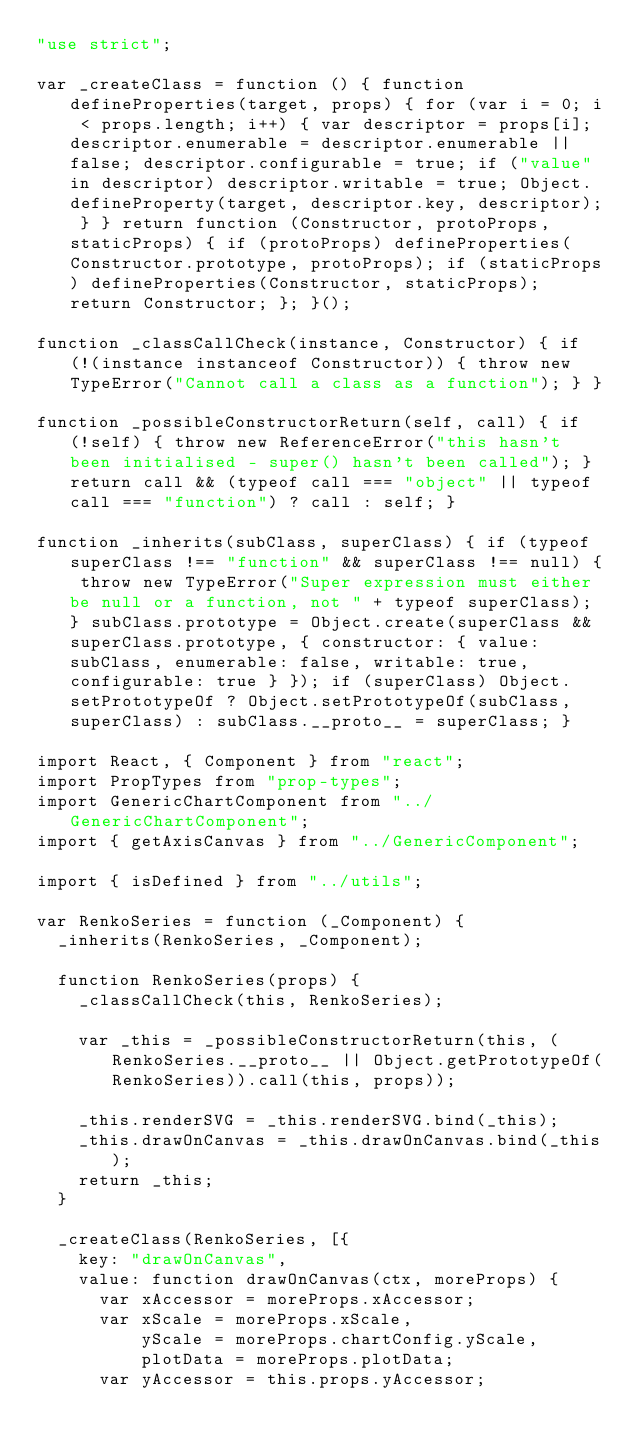Convert code to text. <code><loc_0><loc_0><loc_500><loc_500><_JavaScript_>"use strict";

var _createClass = function () { function defineProperties(target, props) { for (var i = 0; i < props.length; i++) { var descriptor = props[i]; descriptor.enumerable = descriptor.enumerable || false; descriptor.configurable = true; if ("value" in descriptor) descriptor.writable = true; Object.defineProperty(target, descriptor.key, descriptor); } } return function (Constructor, protoProps, staticProps) { if (protoProps) defineProperties(Constructor.prototype, protoProps); if (staticProps) defineProperties(Constructor, staticProps); return Constructor; }; }();

function _classCallCheck(instance, Constructor) { if (!(instance instanceof Constructor)) { throw new TypeError("Cannot call a class as a function"); } }

function _possibleConstructorReturn(self, call) { if (!self) { throw new ReferenceError("this hasn't been initialised - super() hasn't been called"); } return call && (typeof call === "object" || typeof call === "function") ? call : self; }

function _inherits(subClass, superClass) { if (typeof superClass !== "function" && superClass !== null) { throw new TypeError("Super expression must either be null or a function, not " + typeof superClass); } subClass.prototype = Object.create(superClass && superClass.prototype, { constructor: { value: subClass, enumerable: false, writable: true, configurable: true } }); if (superClass) Object.setPrototypeOf ? Object.setPrototypeOf(subClass, superClass) : subClass.__proto__ = superClass; }

import React, { Component } from "react";
import PropTypes from "prop-types";
import GenericChartComponent from "../GenericChartComponent";
import { getAxisCanvas } from "../GenericComponent";

import { isDefined } from "../utils";

var RenkoSeries = function (_Component) {
	_inherits(RenkoSeries, _Component);

	function RenkoSeries(props) {
		_classCallCheck(this, RenkoSeries);

		var _this = _possibleConstructorReturn(this, (RenkoSeries.__proto__ || Object.getPrototypeOf(RenkoSeries)).call(this, props));

		_this.renderSVG = _this.renderSVG.bind(_this);
		_this.drawOnCanvas = _this.drawOnCanvas.bind(_this);
		return _this;
	}

	_createClass(RenkoSeries, [{
		key: "drawOnCanvas",
		value: function drawOnCanvas(ctx, moreProps) {
			var xAccessor = moreProps.xAccessor;
			var xScale = moreProps.xScale,
			    yScale = moreProps.chartConfig.yScale,
			    plotData = moreProps.plotData;
			var yAccessor = this.props.yAccessor;

</code> 